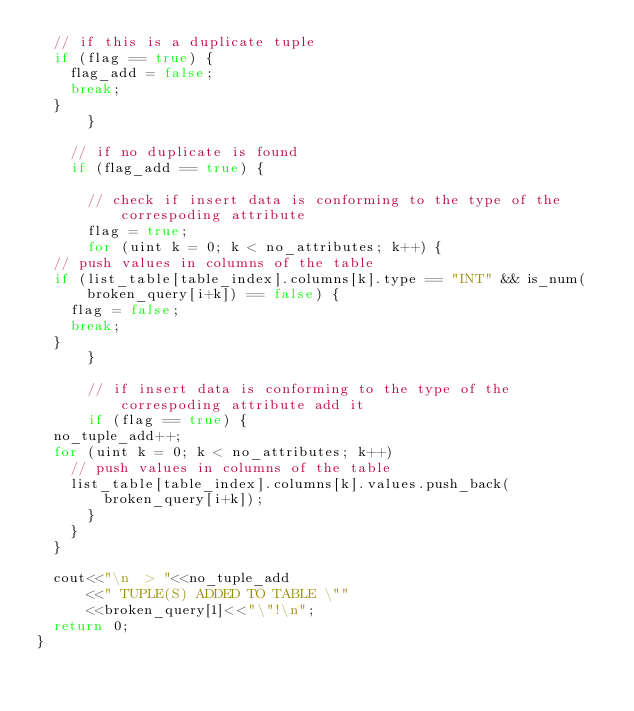<code> <loc_0><loc_0><loc_500><loc_500><_C++_>	// if this is a duplicate tuple
	if (flag == true) {
	  flag_add = false;
	  break;
	}
      }    
    
    // if no duplicate is found
    if (flag_add == true) {

      // check if insert data is conforming to the type of the correspoding attribute
      flag = true;
      for (uint k = 0; k < no_attributes; k++) {
	// push values in columns of the table
	if (list_table[table_index].columns[k].type == "INT" && is_num(broken_query[i+k]) == false) {
	  flag = false;
	  break;
	}
      }

      // if insert data is conforming to the type of the correspoding attribute add it 
      if (flag == true) {
	no_tuple_add++;
	for (uint k = 0; k < no_attributes; k++) 
	  // push values in columns of the table
	  list_table[table_index].columns[k].values.push_back(broken_query[i+k]);
      }	  
    }
  }
  
  cout<<"\n  > "<<no_tuple_add
      <<" TUPLE(S) ADDED TO TABLE \""
      <<broken_query[1]<<"\"!\n";
  return 0;
}
</code> 